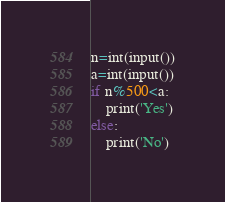<code> <loc_0><loc_0><loc_500><loc_500><_Python_>n=int(input())
a=int(input())
if n%500<a:
    print('Yes')
else:
    print('No')</code> 